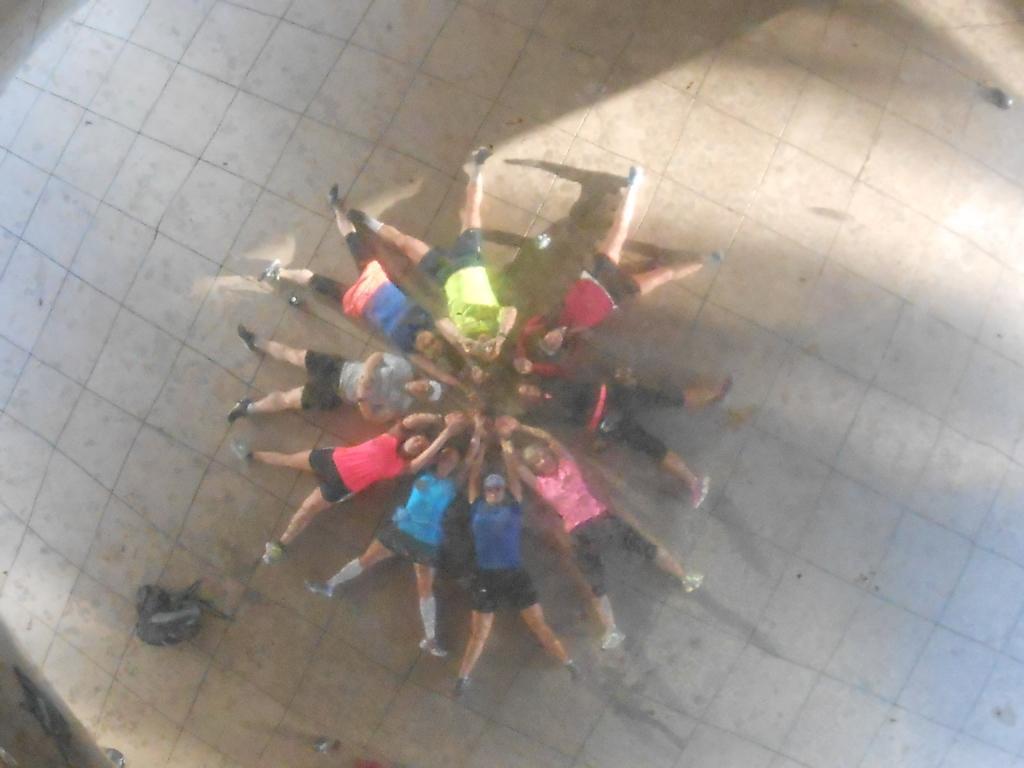Can you describe this image briefly? In this image we see a group of persons are lying on the ground. 